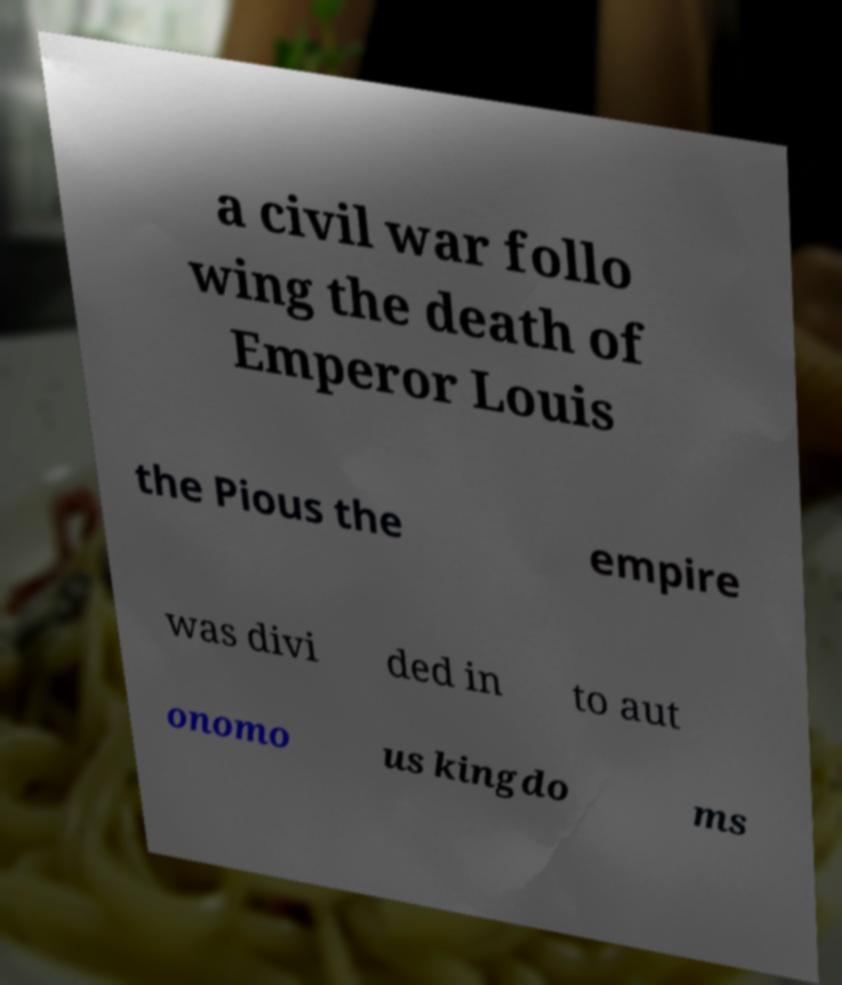Could you extract and type out the text from this image? a civil war follo wing the death of Emperor Louis the Pious the empire was divi ded in to aut onomo us kingdo ms 